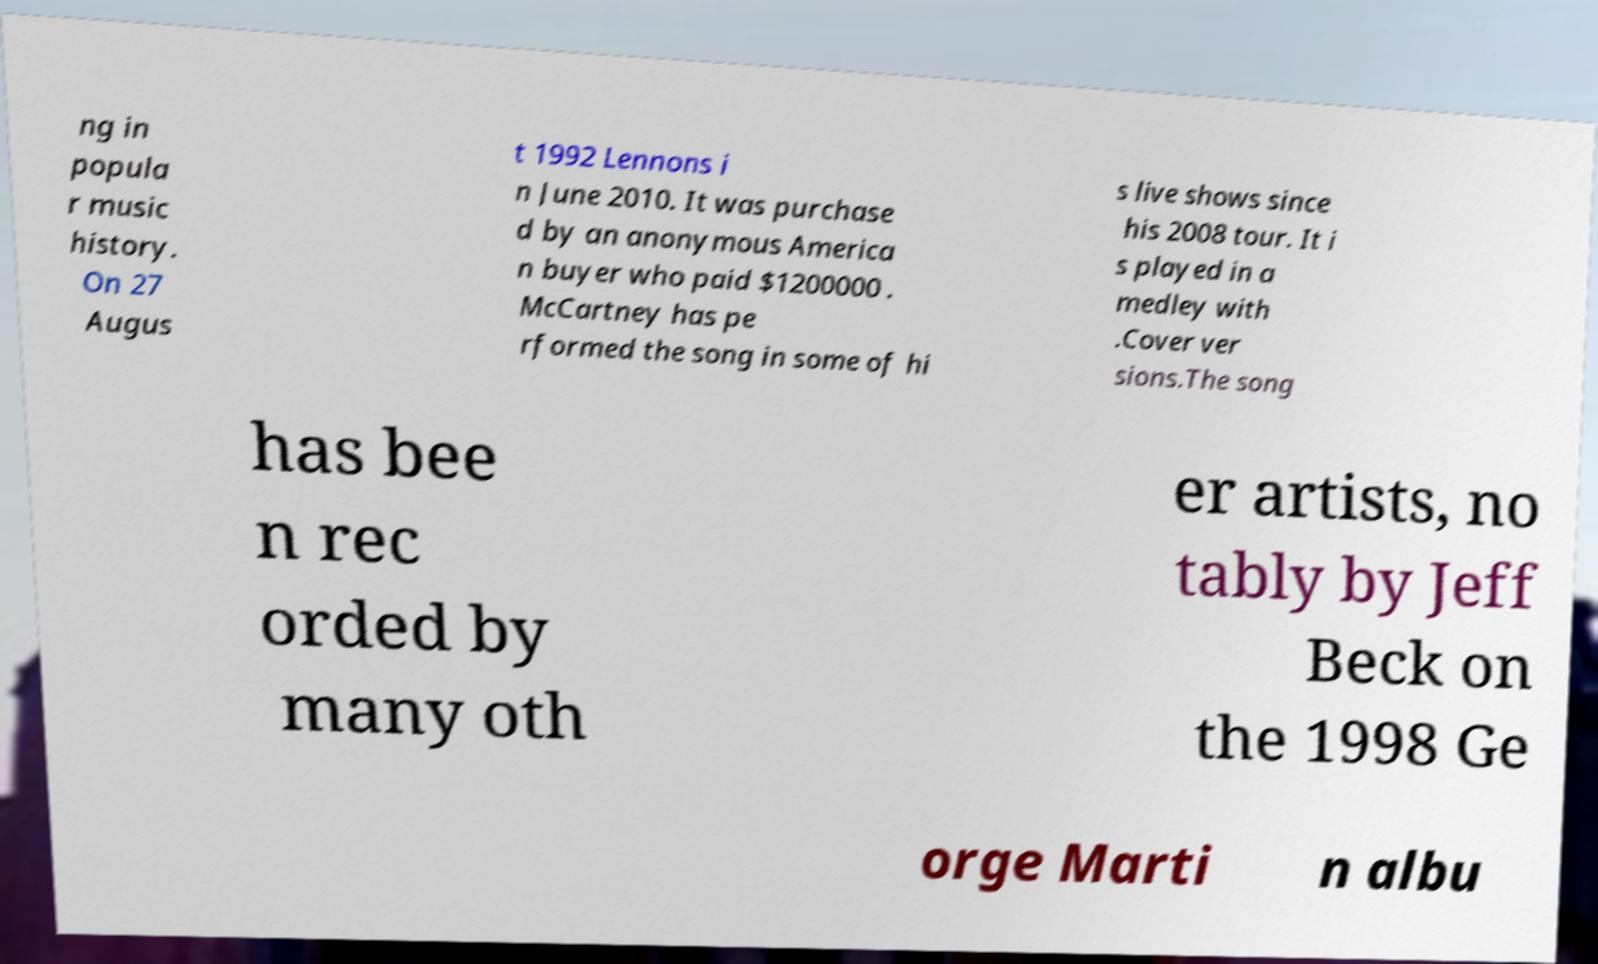For documentation purposes, I need the text within this image transcribed. Could you provide that? ng in popula r music history. On 27 Augus t 1992 Lennons i n June 2010. It was purchase d by an anonymous America n buyer who paid $1200000 . McCartney has pe rformed the song in some of hi s live shows since his 2008 tour. It i s played in a medley with .Cover ver sions.The song has bee n rec orded by many oth er artists, no tably by Jeff Beck on the 1998 Ge orge Marti n albu 